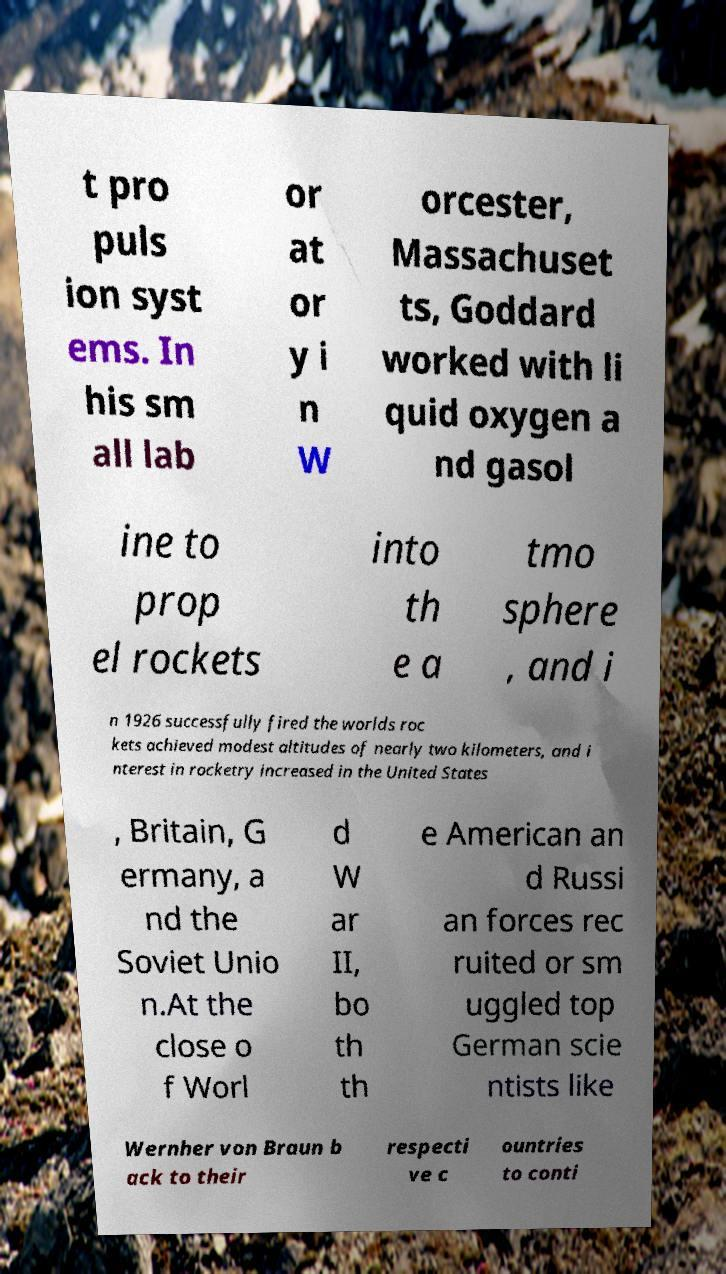Please read and relay the text visible in this image. What does it say? t pro puls ion syst ems. In his sm all lab or at or y i n W orcester, Massachuset ts, Goddard worked with li quid oxygen a nd gasol ine to prop el rockets into th e a tmo sphere , and i n 1926 successfully fired the worlds roc kets achieved modest altitudes of nearly two kilometers, and i nterest in rocketry increased in the United States , Britain, G ermany, a nd the Soviet Unio n.At the close o f Worl d W ar II, bo th th e American an d Russi an forces rec ruited or sm uggled top German scie ntists like Wernher von Braun b ack to their respecti ve c ountries to conti 